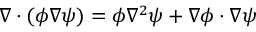Convert formula to latex. <formula><loc_0><loc_0><loc_500><loc_500>\nabla \cdot ( \phi \nabla \psi ) = \phi \nabla ^ { 2 } \psi + \nabla \phi \cdot \nabla \psi</formula> 